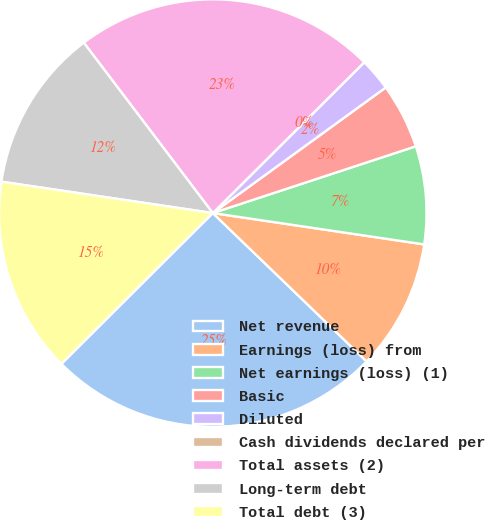Convert chart to OTSL. <chart><loc_0><loc_0><loc_500><loc_500><pie_chart><fcel>Net revenue<fcel>Earnings (loss) from<fcel>Net earnings (loss) (1)<fcel>Basic<fcel>Diluted<fcel>Cash dividends declared per<fcel>Total assets (2)<fcel>Long-term debt<fcel>Total debt (3)<nl><fcel>25.32%<fcel>9.87%<fcel>7.4%<fcel>4.94%<fcel>2.47%<fcel>0.0%<fcel>22.85%<fcel>12.34%<fcel>14.81%<nl></chart> 